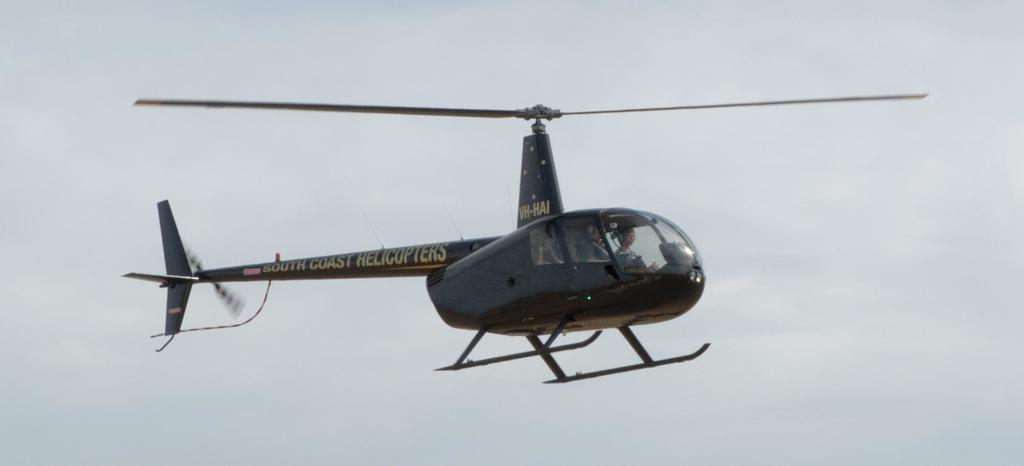What is the main subject of the image? The main subject of the image is a helicopter. What color is the helicopter? The helicopter is black in color. What is the helicopter doing in the image? The helicopter is flying in the air. How many people are inside the helicopter? There are two persons in the helicopter. What can be seen in the background of the image? The sky is visible in the background of the image. What type of patch is being sewn onto the helicopter's wing in the image? There is no patch being sewn onto the helicopter's wing in the image; the helicopter is simply flying in the air. What account number is associated with the helicopter in the image? There is no account number associated with the helicopter in the image, as it is a photograph and not a financial record. 